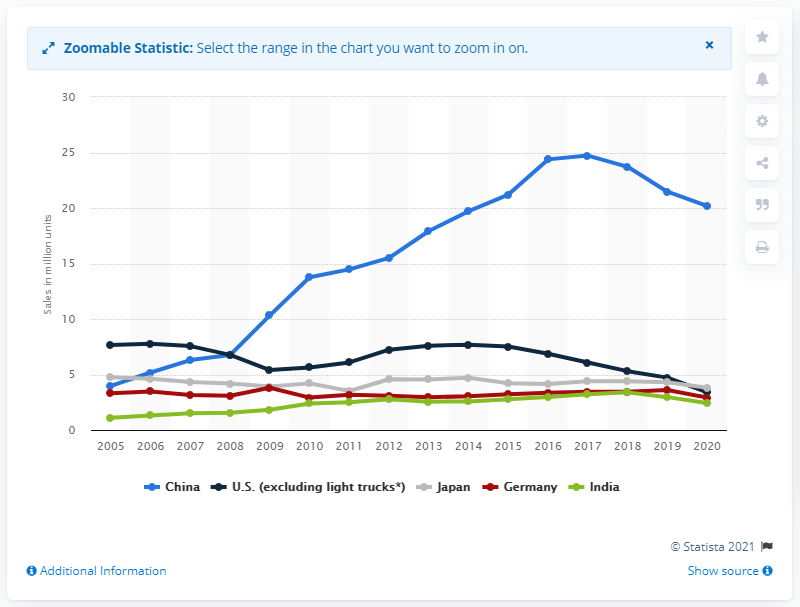Draw attention to some important aspects in this diagram. In 2020, a significant number of passenger cars were sold in China. 